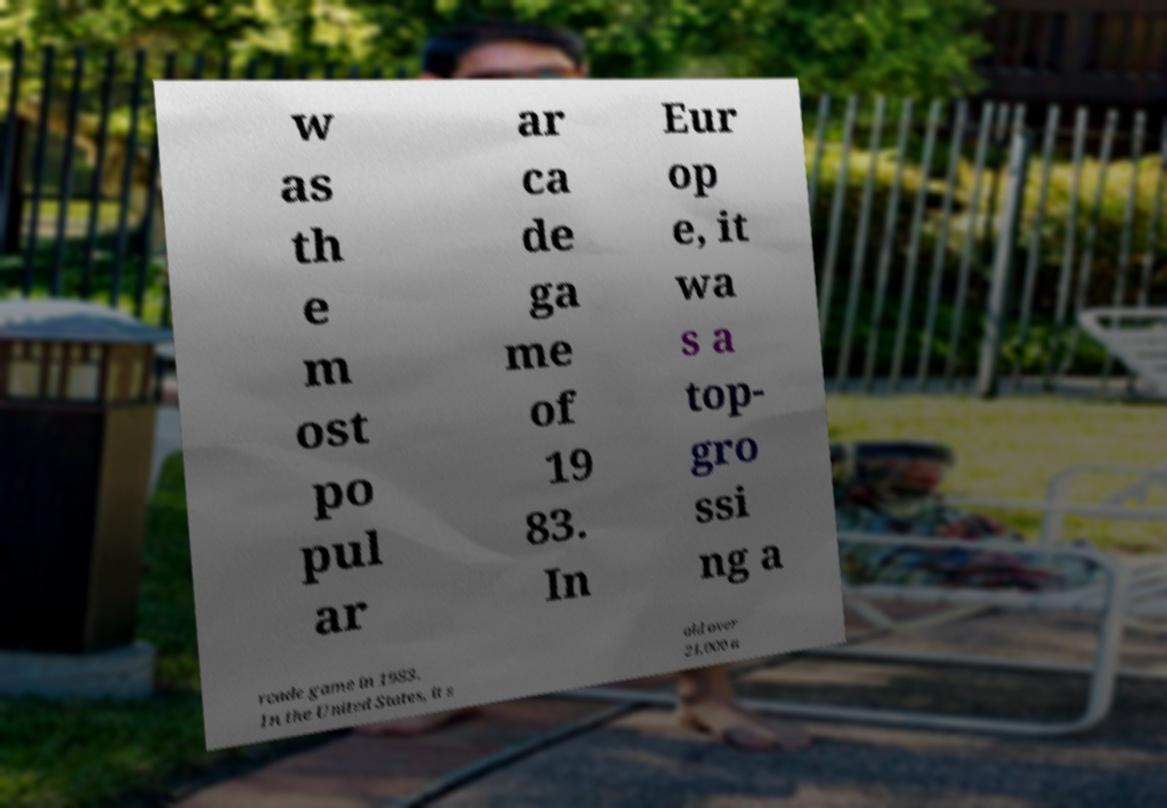There's text embedded in this image that I need extracted. Can you transcribe it verbatim? w as th e m ost po pul ar ar ca de ga me of 19 83. In Eur op e, it wa s a top- gro ssi ng a rcade game in 1983. In the United States, it s old over 21,000 a 